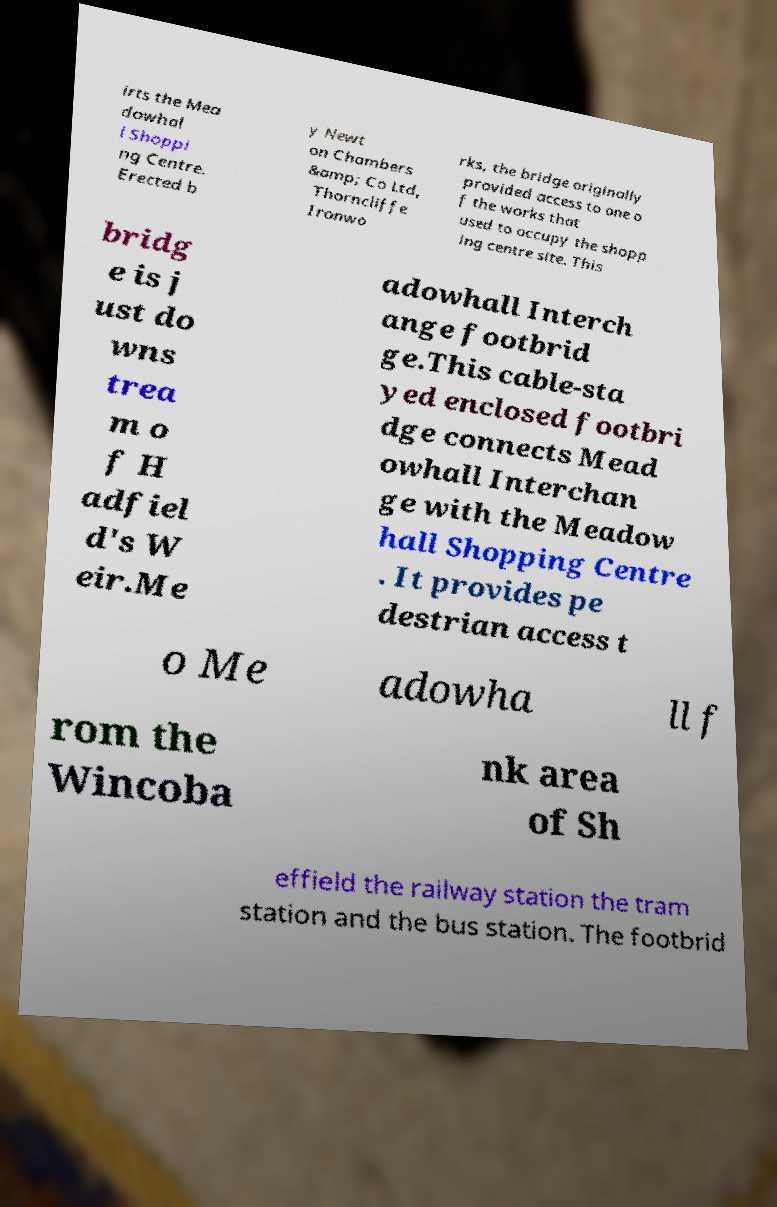There's text embedded in this image that I need extracted. Can you transcribe it verbatim? irts the Mea dowhal l Shoppi ng Centre. Erected b y Newt on Chambers &amp; Co Ltd, Thorncliffe Ironwo rks, the bridge originally provided access to one o f the works that used to occupy the shopp ing centre site. This bridg e is j ust do wns trea m o f H adfiel d's W eir.Me adowhall Interch ange footbrid ge.This cable-sta yed enclosed footbri dge connects Mead owhall Interchan ge with the Meadow hall Shopping Centre . It provides pe destrian access t o Me adowha ll f rom the Wincoba nk area of Sh effield the railway station the tram station and the bus station. The footbrid 